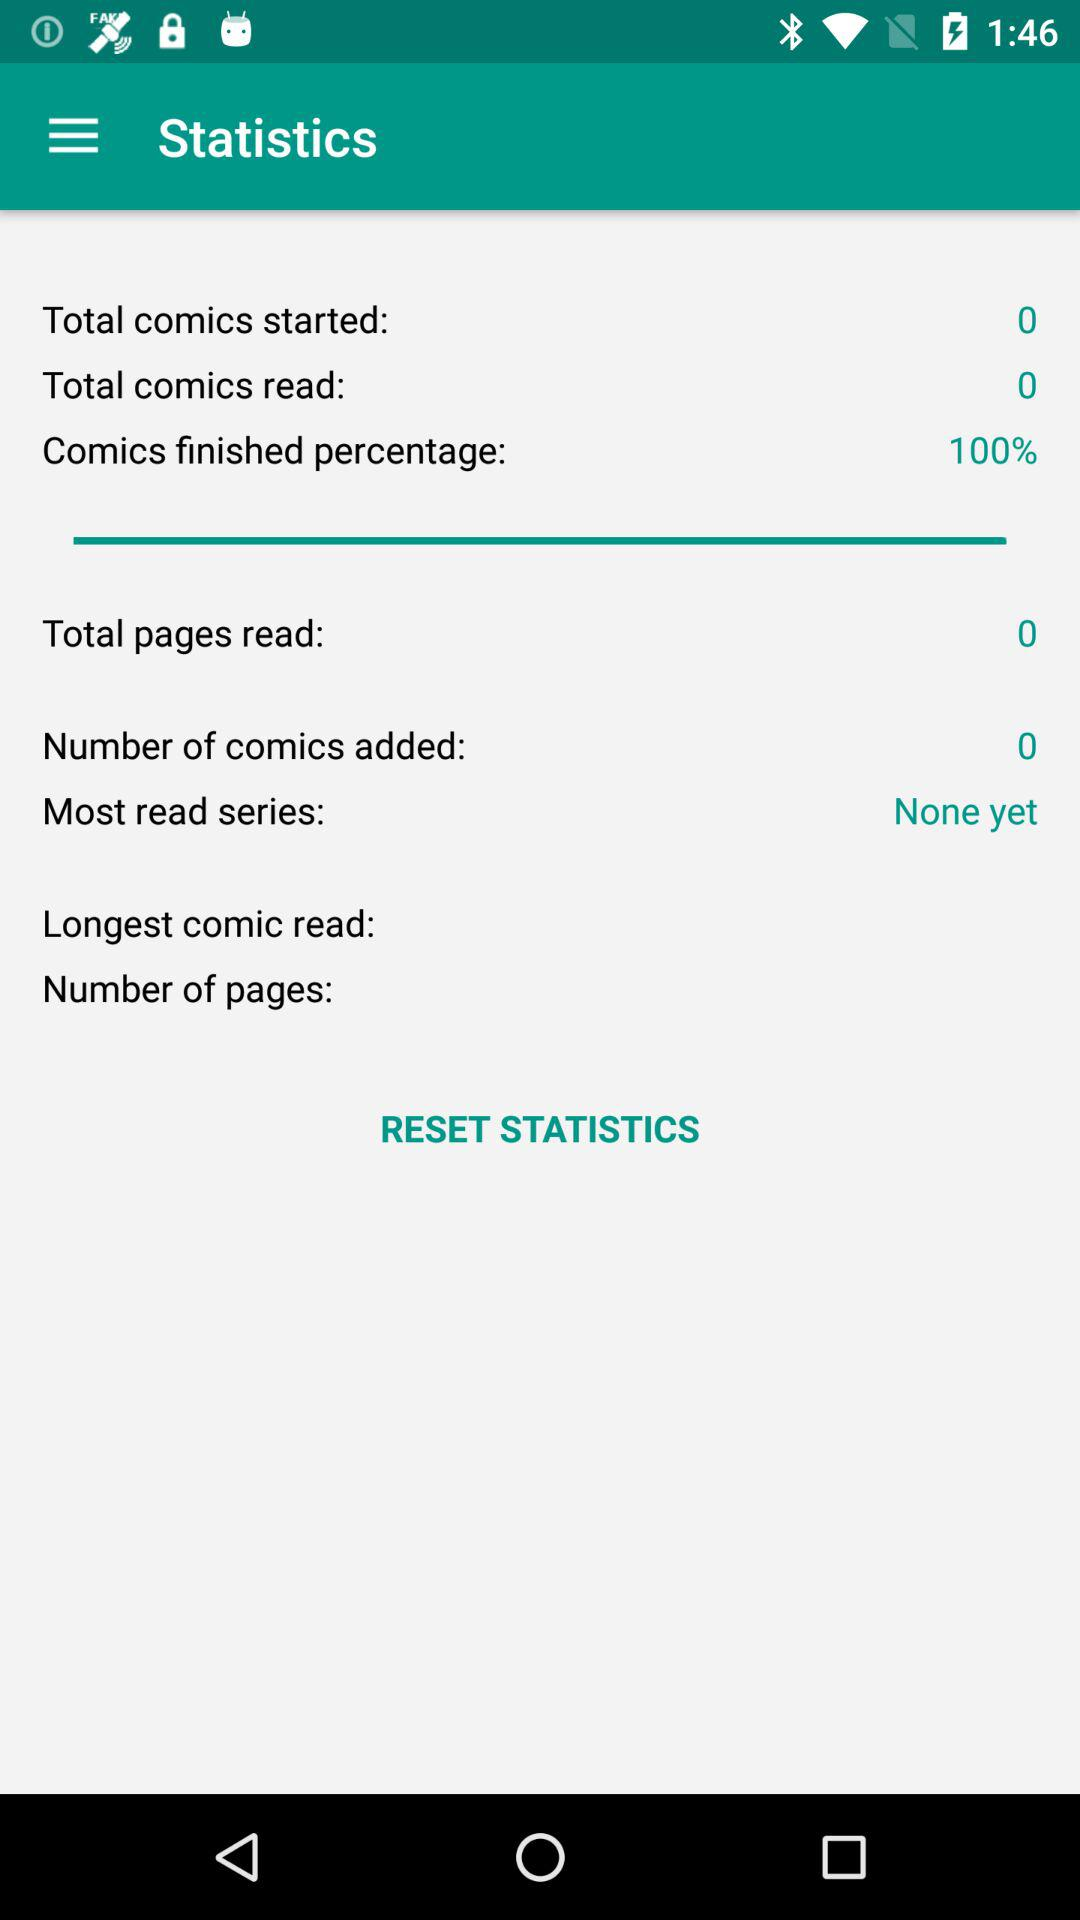Is there any most read series? The most read series is none yet. 